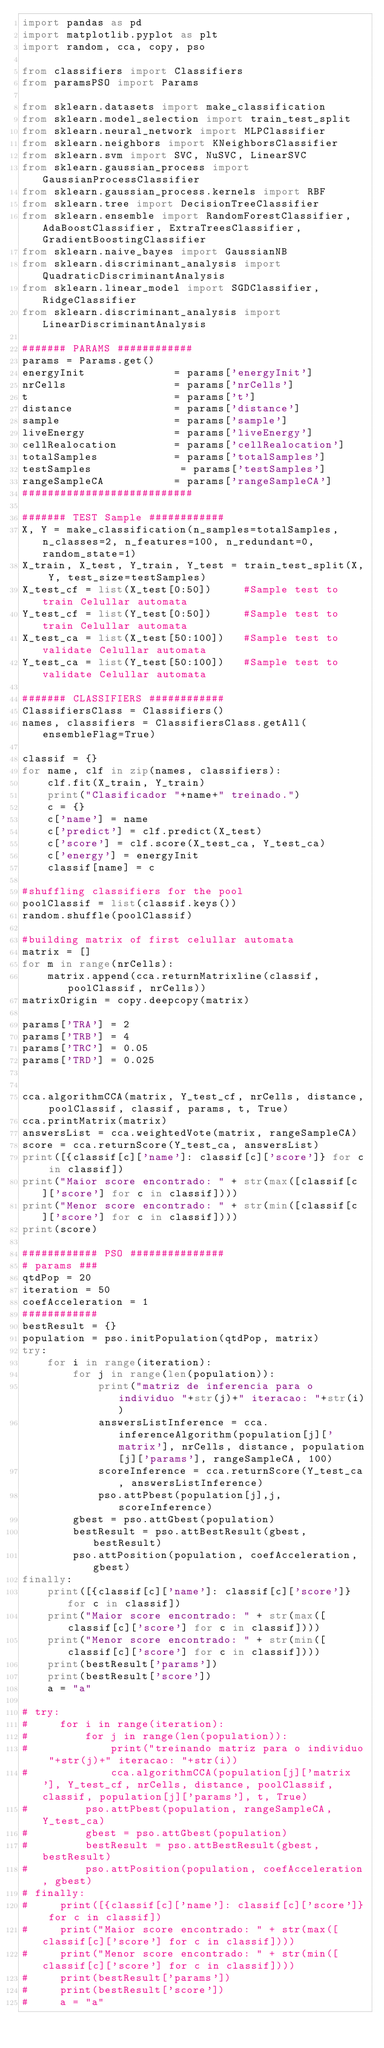<code> <loc_0><loc_0><loc_500><loc_500><_Python_>import pandas as pd
import matplotlib.pyplot as plt
import random, cca, copy, pso

from classifiers import Classifiers
from paramsPSO import Params

from sklearn.datasets import make_classification
from sklearn.model_selection import train_test_split
from sklearn.neural_network import MLPClassifier
from sklearn.neighbors import KNeighborsClassifier
from sklearn.svm import SVC, NuSVC, LinearSVC
from sklearn.gaussian_process import GaussianProcessClassifier
from sklearn.gaussian_process.kernels import RBF
from sklearn.tree import DecisionTreeClassifier
from sklearn.ensemble import RandomForestClassifier, AdaBoostClassifier, ExtraTreesClassifier, GradientBoostingClassifier
from sklearn.naive_bayes import GaussianNB
from sklearn.discriminant_analysis import QuadraticDiscriminantAnalysis
from sklearn.linear_model import SGDClassifier, RidgeClassifier
from sklearn.discriminant_analysis import LinearDiscriminantAnalysis

####### PARAMS ############
params = Params.get()
energyInit              = params['energyInit']
nrCells                 = params['nrCells']
t                       = params['t']
distance                = params['distance']
sample                  = params['sample']
liveEnergy              = params['liveEnergy']
cellRealocation         = params['cellRealocation']
totalSamples            = params['totalSamples']
testSamples              = params['testSamples']
rangeSampleCA           = params['rangeSampleCA']
###########################

####### TEST Sample ############
X, Y = make_classification(n_samples=totalSamples, n_classes=2, n_features=100, n_redundant=0, random_state=1)
X_train, X_test, Y_train, Y_test = train_test_split(X, Y, test_size=testSamples)
X_test_cf = list(X_test[0:50])     #Sample test to train Celullar automata
Y_test_cf = list(Y_test[0:50])     #Sample test to train Celullar automata
X_test_ca = list(X_test[50:100])   #Sample test to validate Celullar automata
Y_test_ca = list(Y_test[50:100])   #Sample test to validate Celullar automata

####### CLASSIFIERS ############
ClassifiersClass = Classifiers()
names, classifiers = ClassifiersClass.getAll(ensembleFlag=True)

classif = {}
for name, clf in zip(names, classifiers):
    clf.fit(X_train, Y_train)
    print("Clasificador "+name+" treinado.")
    c = {}
    c['name'] = name
    c['predict'] = clf.predict(X_test)
    c['score'] = clf.score(X_test_ca, Y_test_ca)
    c['energy'] = energyInit
    classif[name] = c

#shuffling classifiers for the pool
poolClassif = list(classif.keys())
random.shuffle(poolClassif)

#building matrix of first celullar automata
matrix = []
for m in range(nrCells):
    matrix.append(cca.returnMatrixline(classif, poolClassif, nrCells))
matrixOrigin = copy.deepcopy(matrix)

params['TRA'] = 2
params['TRB'] = 4
params['TRC'] = 0.05
params['TRD'] = 0.025


cca.algorithmCCA(matrix, Y_test_cf, nrCells, distance, poolClassif, classif, params, t, True)
cca.printMatrix(matrix)
answersList = cca.weightedVote(matrix, rangeSampleCA)
score = cca.returnScore(Y_test_ca, answersList)
print([{classif[c]['name']: classif[c]['score']} for c in classif])
print("Maior score encontrado: " + str(max([classif[c]['score'] for c in classif])))
print("Menor score encontrado: " + str(min([classif[c]['score'] for c in classif])))
print(score)

############ PSO ###############
# params ###
qtdPop = 20
iteration = 50
coefAcceleration = 1
############
bestResult = {}
population = pso.initPopulation(qtdPop, matrix)
try:
    for i in range(iteration):
        for j in range(len(population)):
            print("matriz de inferencia para o individuo "+str(j)+" iteracao: "+str(i))
            answersListInference = cca.inferenceAlgorithm(population[j]['matrix'], nrCells, distance, population[j]['params'], rangeSampleCA, 100)
            scoreInference = cca.returnScore(Y_test_ca, answersListInference)
            pso.attPbest(population[j],j, scoreInference)
        gbest = pso.attGbest(population)
        bestResult = pso.attBestResult(gbest, bestResult)
        pso.attPosition(population, coefAcceleration, gbest)
finally: 
    print([{classif[c]['name']: classif[c]['score']} for c in classif])
    print("Maior score encontrado: " + str(max([classif[c]['score'] for c in classif])))
    print("Menor score encontrado: " + str(min([classif[c]['score'] for c in classif])))
    print(bestResult['params'])
    print(bestResult['score'])
    a = "a"

# try:
#     for i in range(iteration):
#         for j in range(len(population)):
#             print("treinando matriz para o individuo "+str(j)+" iteracao: "+str(i))
#             cca.algorithmCCA(population[j]['matrix'], Y_test_cf, nrCells, distance, poolClassif, classif, population[j]['params'], t, True)
#         pso.attPbest(population, rangeSampleCA, Y_test_ca)
#         gbest = pso.attGbest(population)
#         bestResult = pso.attBestResult(gbest, bestResult)
#         pso.attPosition(population, coefAcceleration, gbest)
# finally: 
#     print([{classif[c]['name']: classif[c]['score']} for c in classif])
#     print("Maior score encontrado: " + str(max([classif[c]['score'] for c in classif])))
#     print("Menor score encontrado: " + str(min([classif[c]['score'] for c in classif])))
#     print(bestResult['params'])
#     print(bestResult['score'])
#     a = "a"</code> 